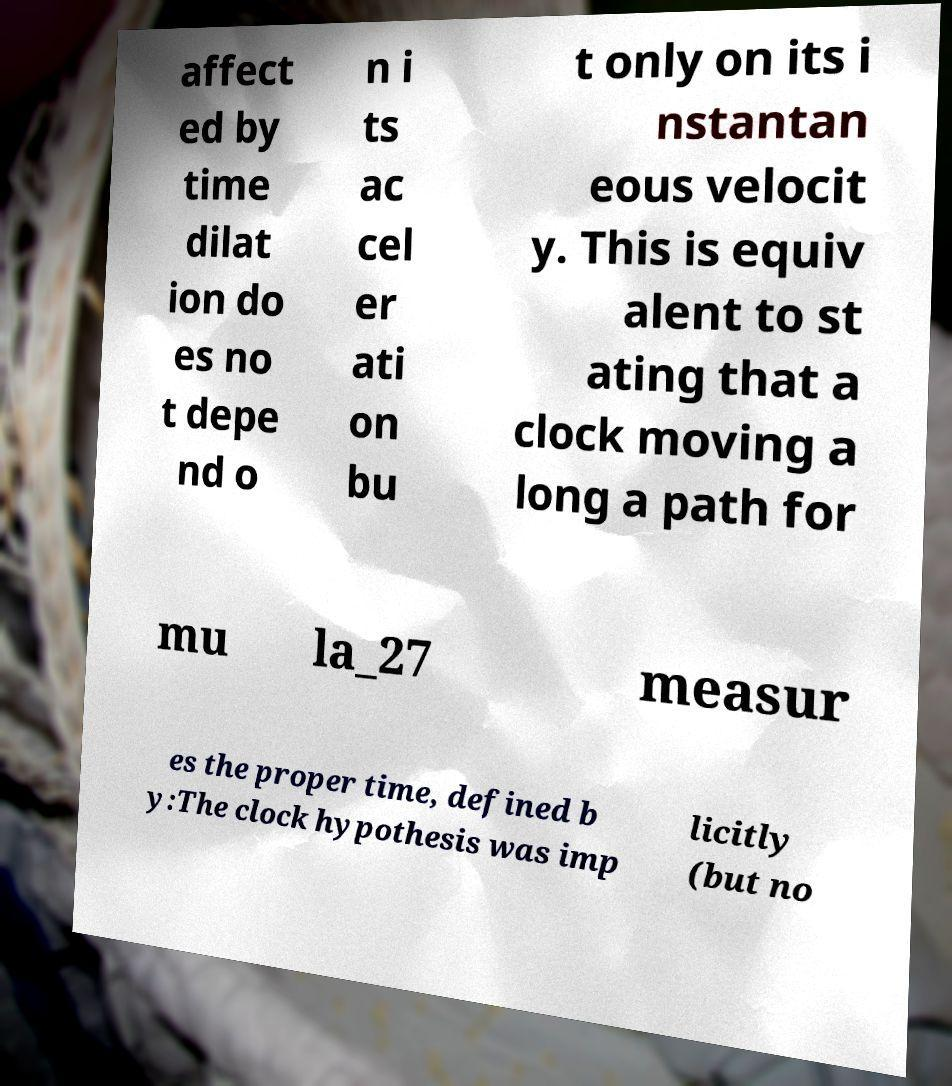What messages or text are displayed in this image? I need them in a readable, typed format. affect ed by time dilat ion do es no t depe nd o n i ts ac cel er ati on bu t only on its i nstantan eous velocit y. This is equiv alent to st ating that a clock moving a long a path for mu la_27 measur es the proper time, defined b y:The clock hypothesis was imp licitly (but no 